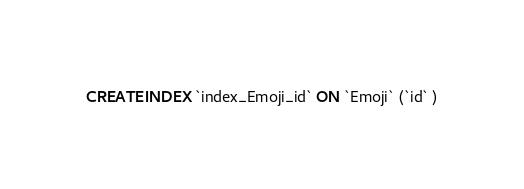<code> <loc_0><loc_0><loc_500><loc_500><_SQL_>CREATE INDEX `index_Emoji_id` ON `Emoji` (`id` )
</code> 